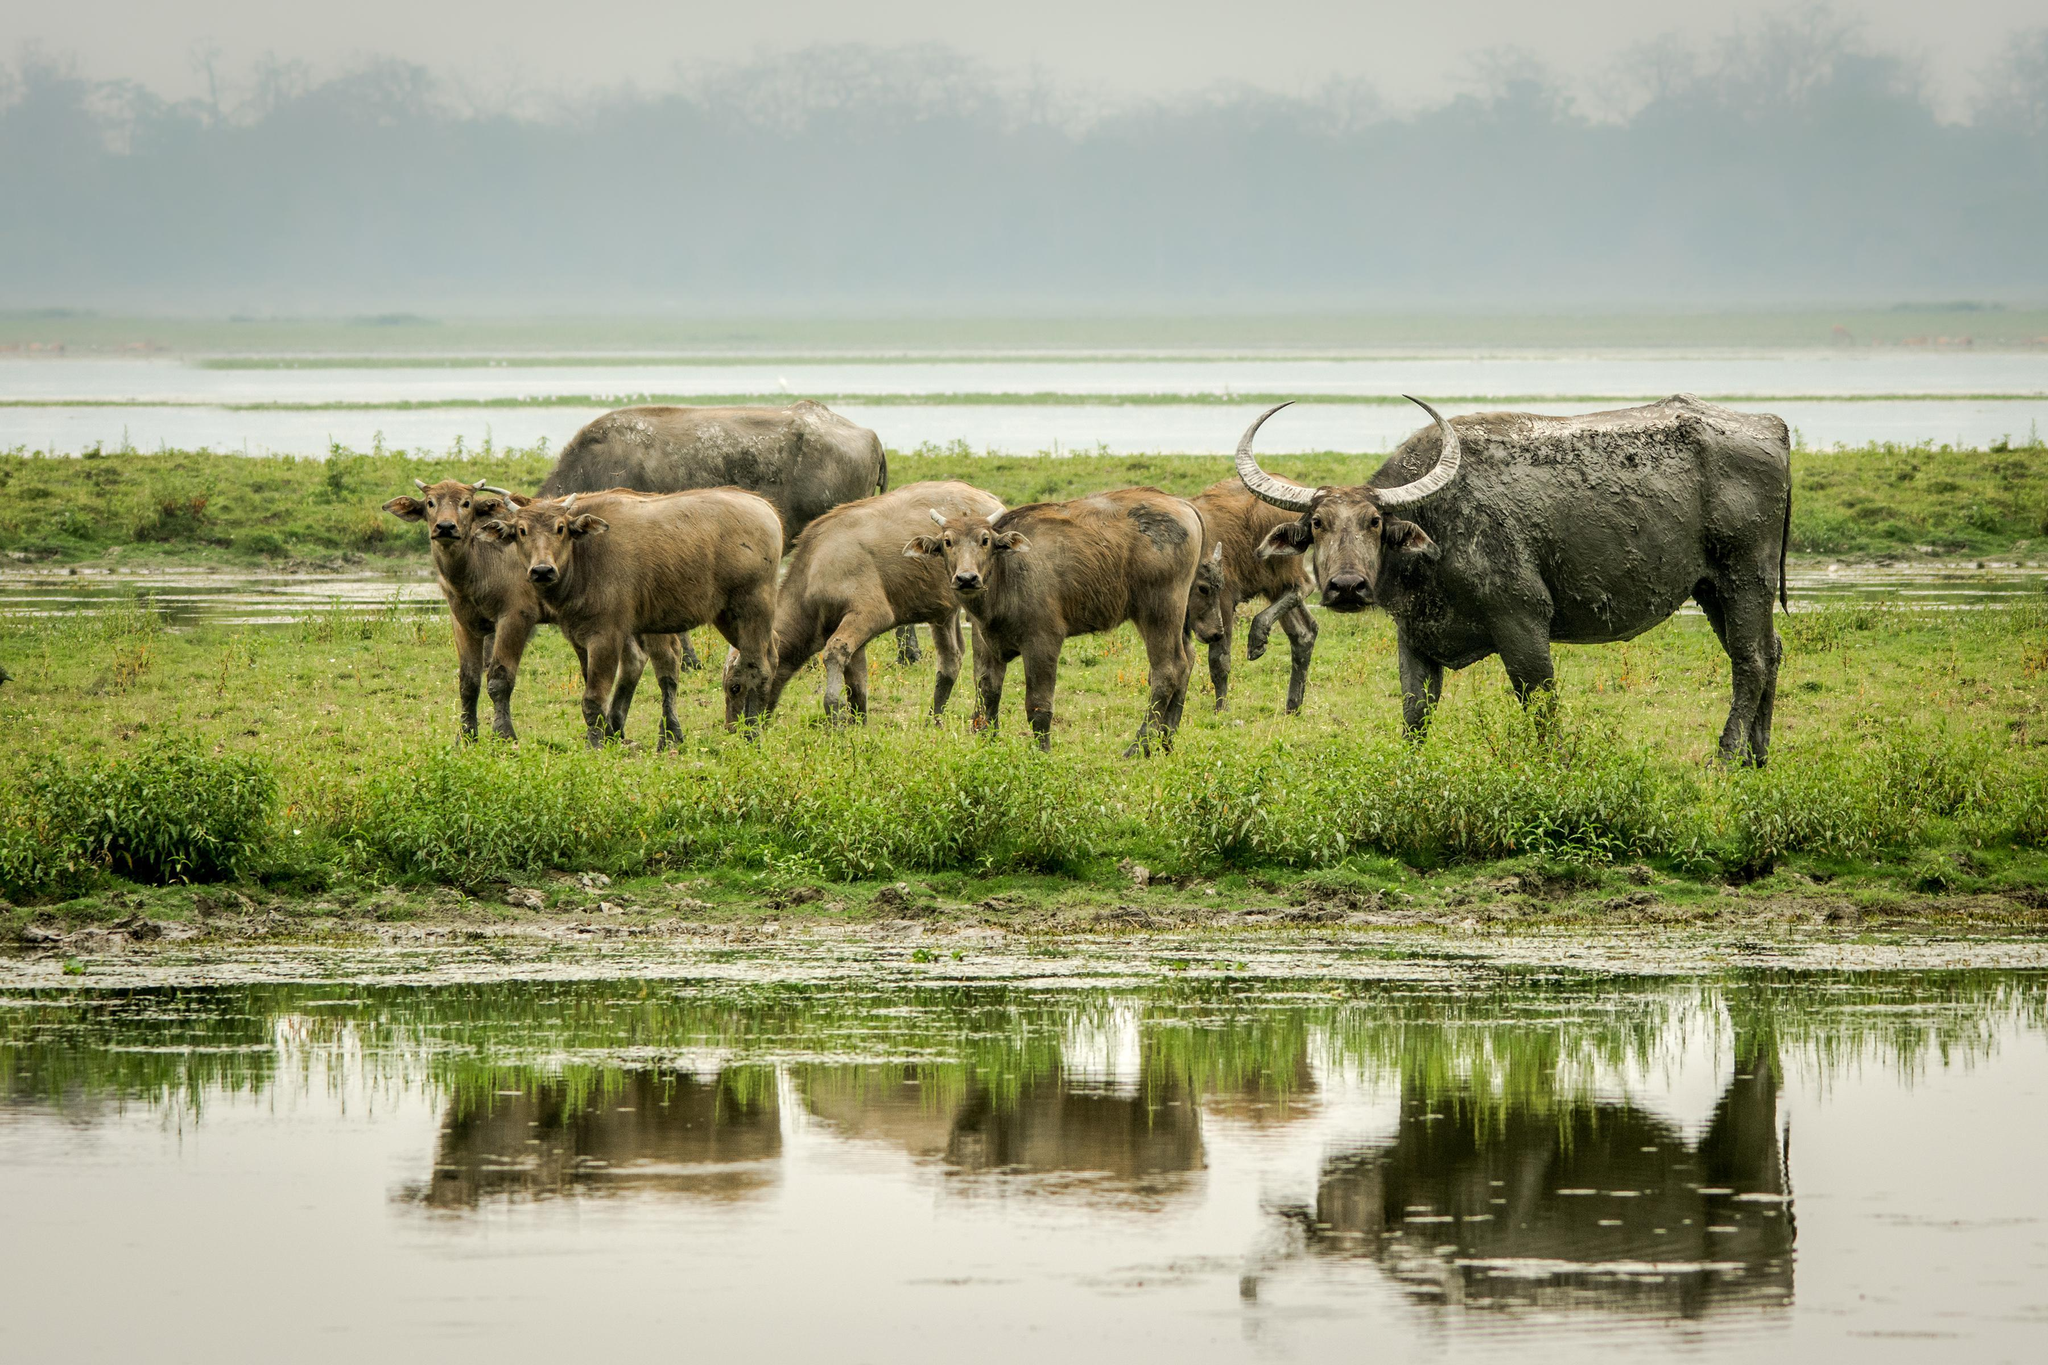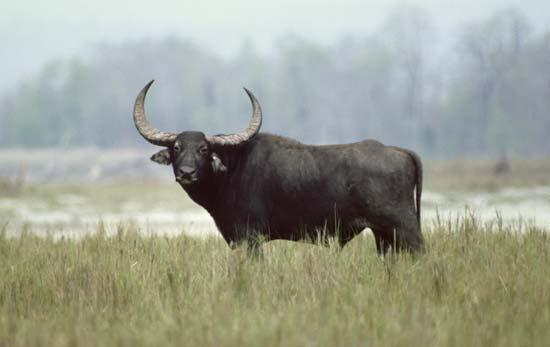The first image is the image on the left, the second image is the image on the right. For the images shown, is this caption "An image contains a water buffalo partially under water." true? Answer yes or no. No. The first image is the image on the left, the second image is the image on the right. For the images displayed, is the sentence "In at least one of the images, a single water buffalo is standing in deep water." factually correct? Answer yes or no. No. 